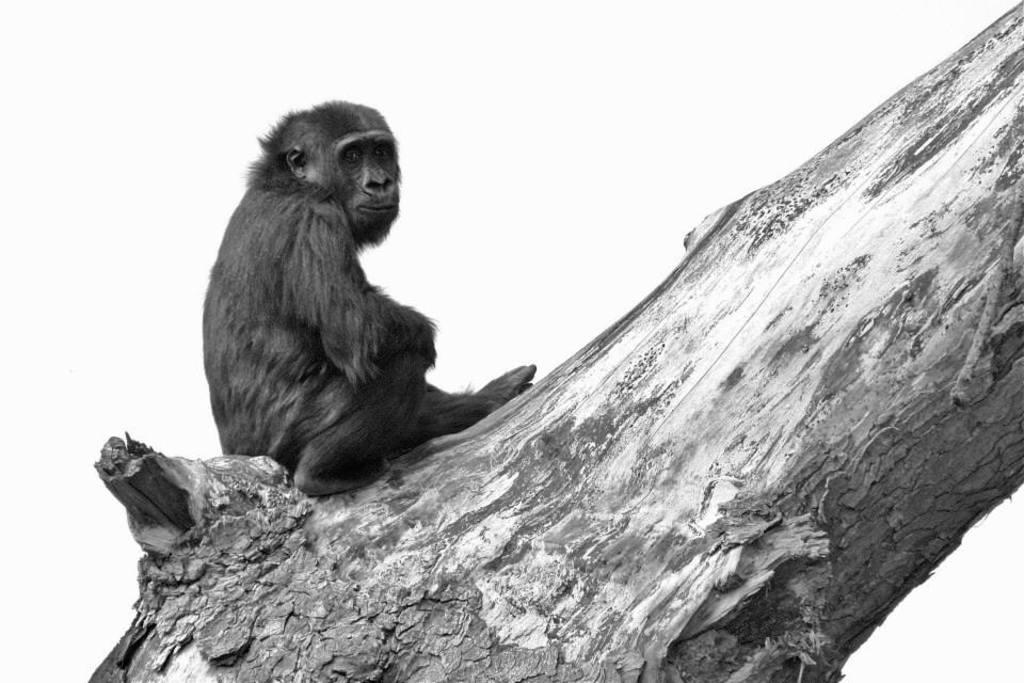What animal is present in the image? There is a monkey in the image. Where is the monkey located? The monkey is on the bark of a tree. What can be seen in the background of the image? There is sky visible in the background of the image. What type of cloth is the monkey using to climb the tree in the image? There is no cloth present in the image, and the monkey is not using any cloth to climb the tree. 